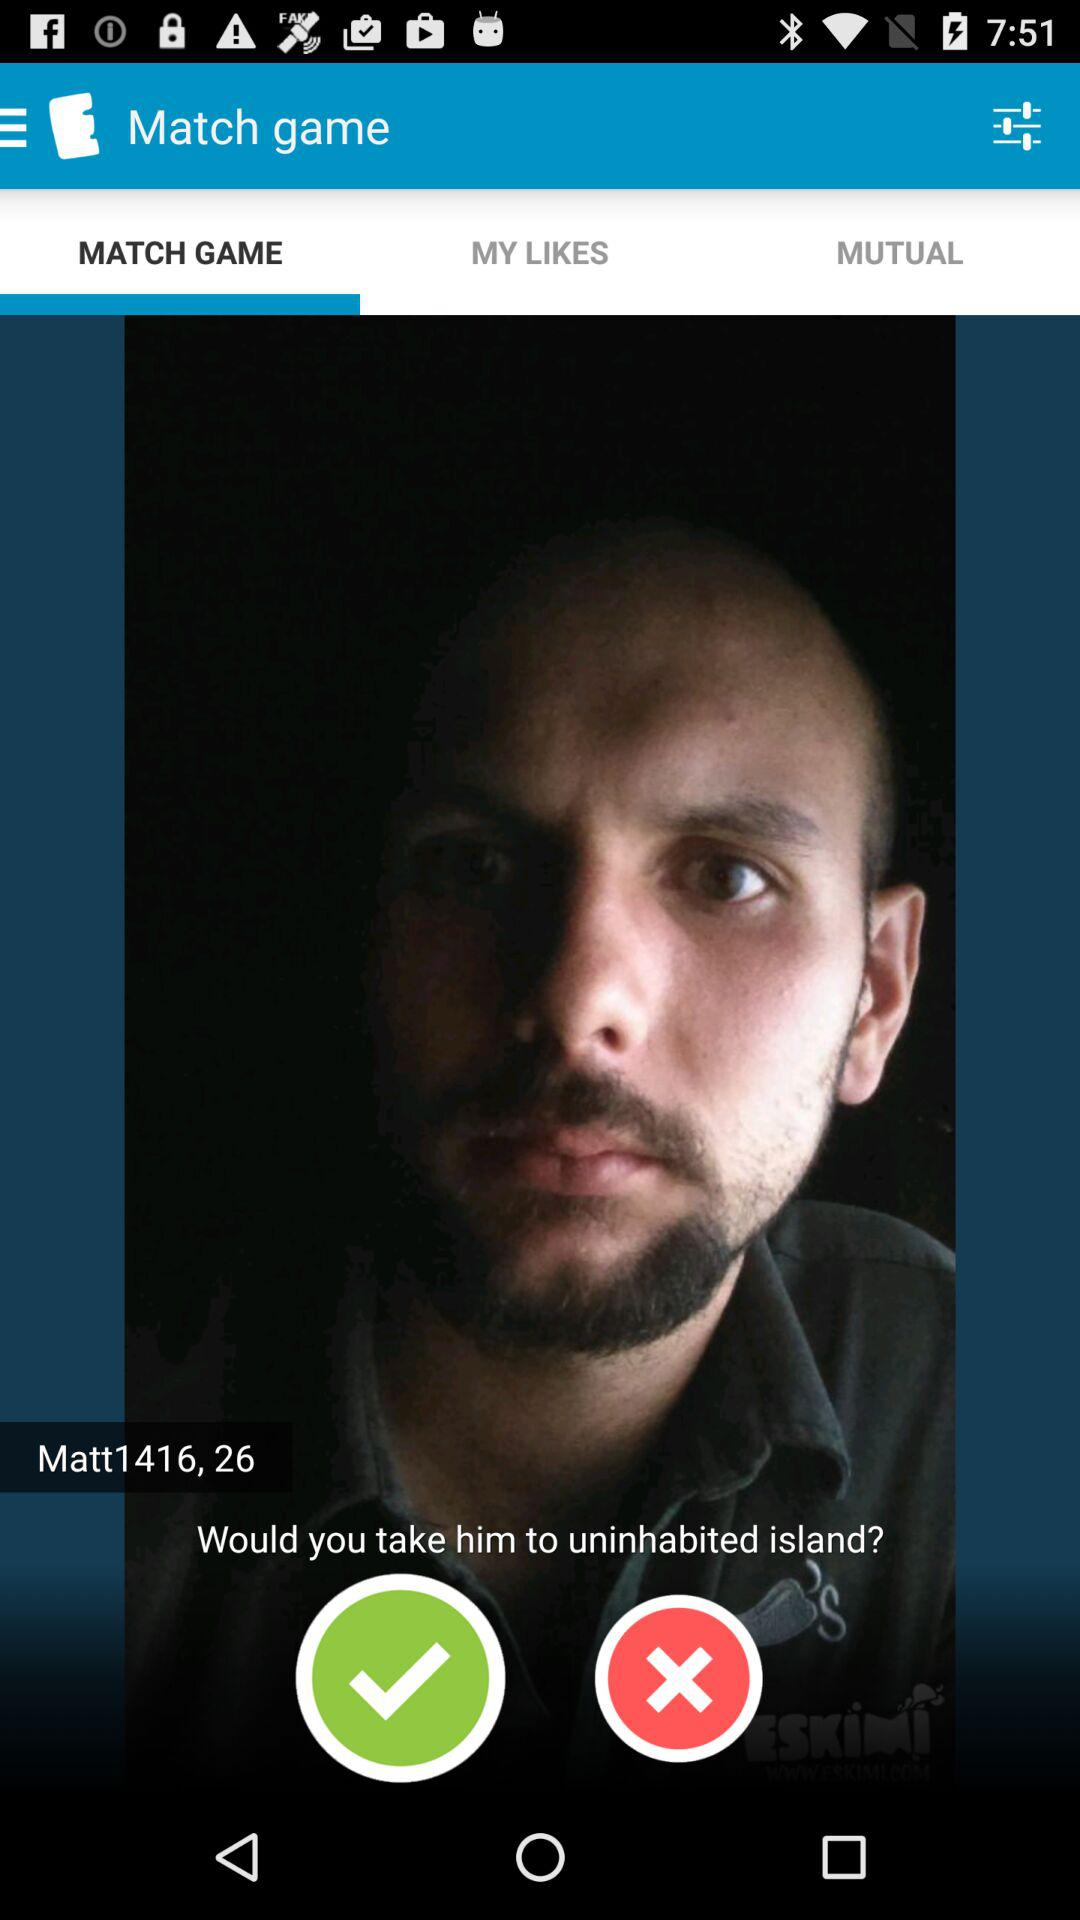Which tab is selected? The selected tab is "MATCH GAME". 